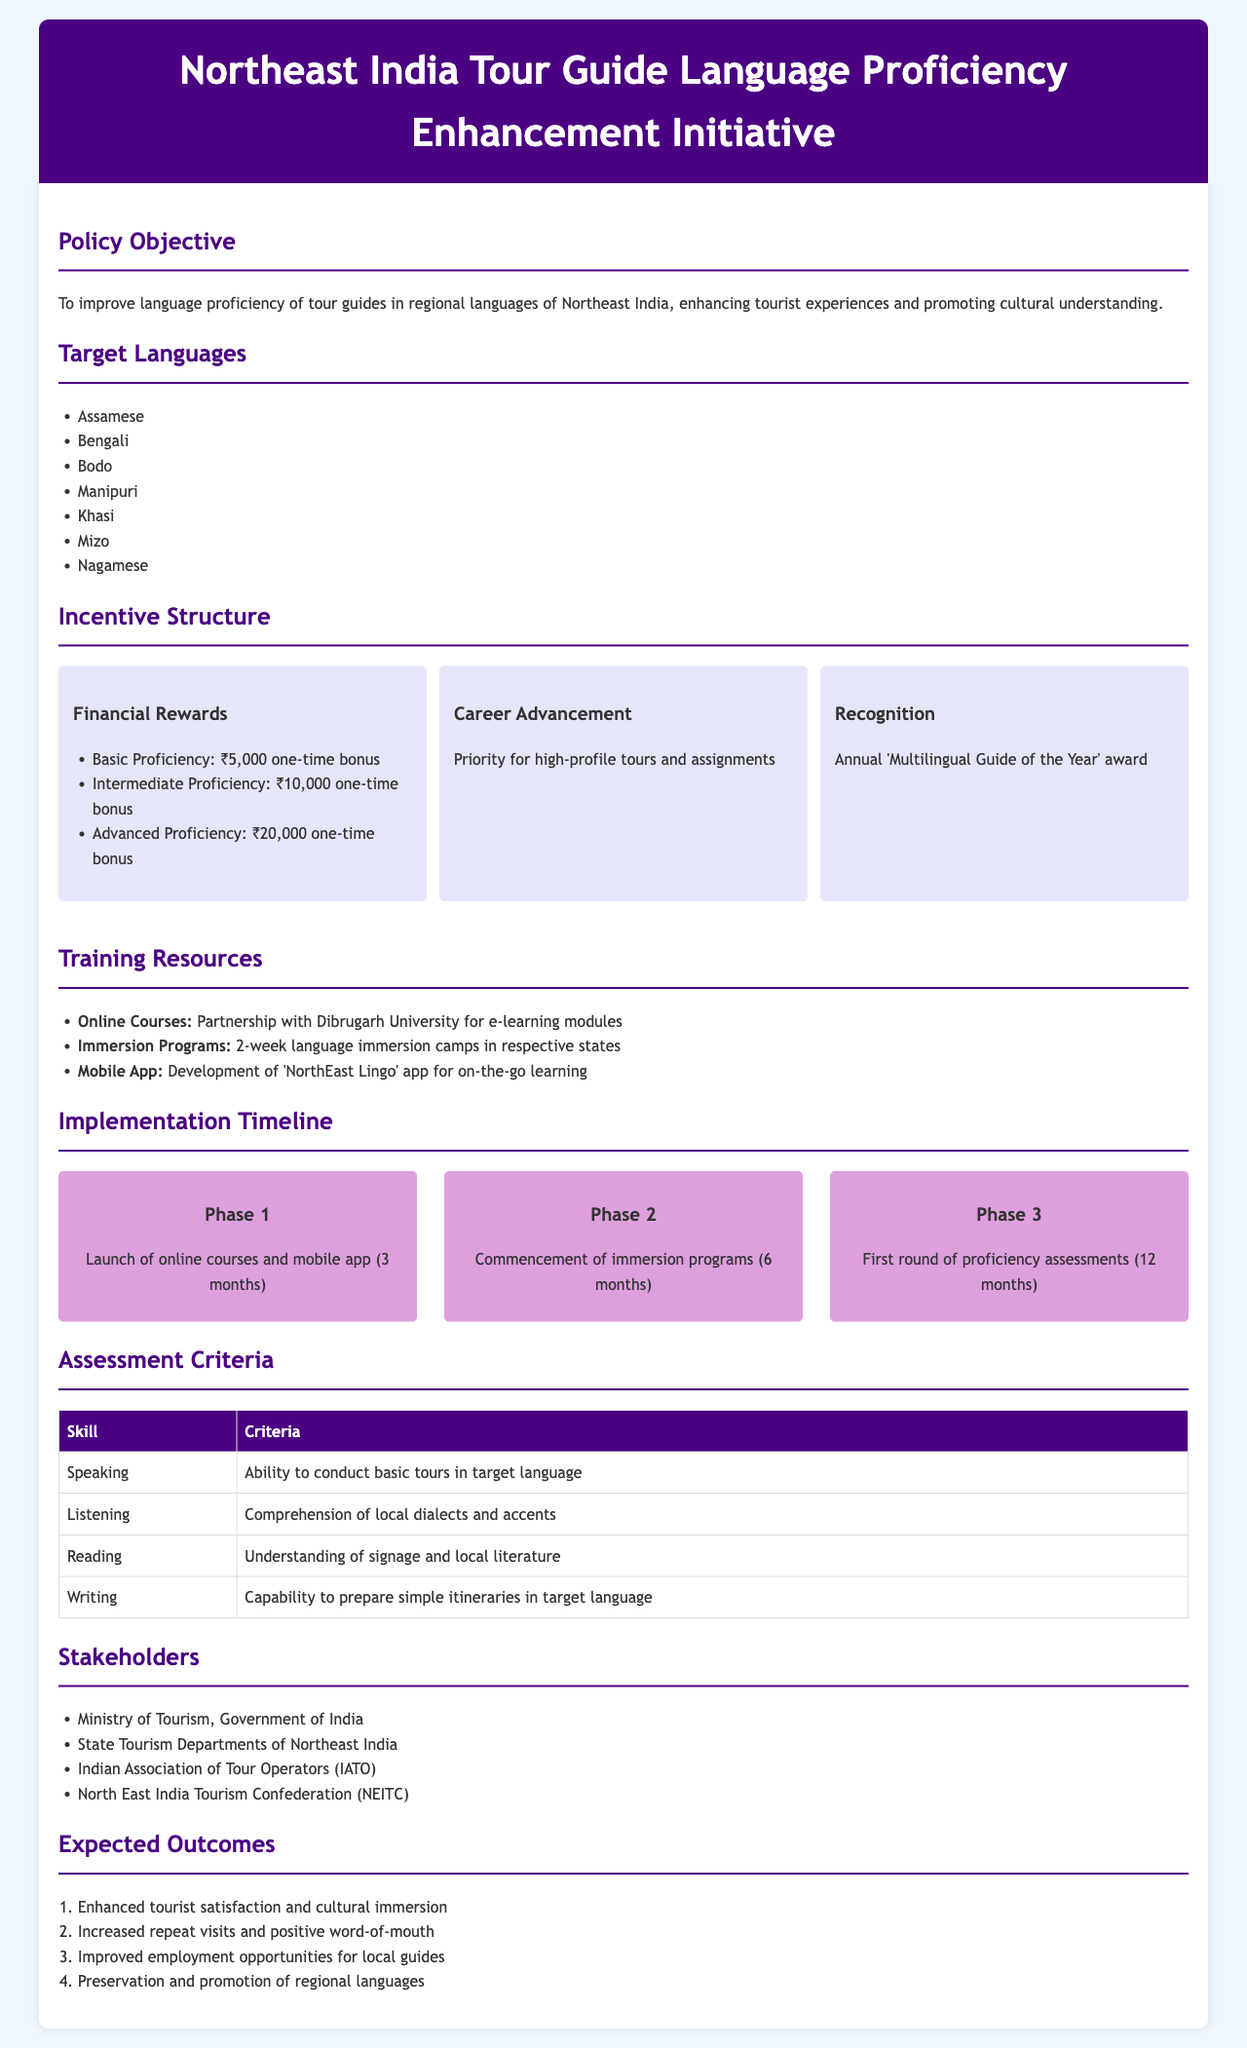What is the policy objective? The policy objective is stated as improving language proficiency of tour guides in regional languages of Northeast India, enhancing tourist experiences and promoting cultural understanding.
Answer: Improving language proficiency What are the target languages? The target languages listed in the document are Assamese, Bengali, Bodo, Manipuri, Khasi, Mizo, and Nagamese.
Answer: Assamese, Bengali, Bodo, Manipuri, Khasi, Mizo, Nagamese What is the financial reward for advanced proficiency? The document specifies a financial reward of ₹20,000 for achieving advanced proficiency in the target languages.
Answer: ₹20,000 How long will the immersion programs last? According to the document, the immersion programs will last for two weeks.
Answer: 2 weeks What will be awarded annually to exceptional tour guides? The document mentions an annual award for the 'Multilingual Guide of the Year' as recognition for exceptional tour guides.
Answer: 'Multilingual Guide of the Year' award What is the first phase of the implementation timeline? The first phase involves the launch of online courses and mobile app over a period of 3 months.
Answer: Launch of online courses and mobile app What stakeholder is responsible for the policy? The Ministry of Tourism, Government of India is one of the main stakeholders responsible for the policy.
Answer: Ministry of Tourism, Government of India What is one expected outcome of the initiative? One expected outcome listed is enhanced tourist satisfaction and cultural immersion.
Answer: Enhanced tourist satisfaction 